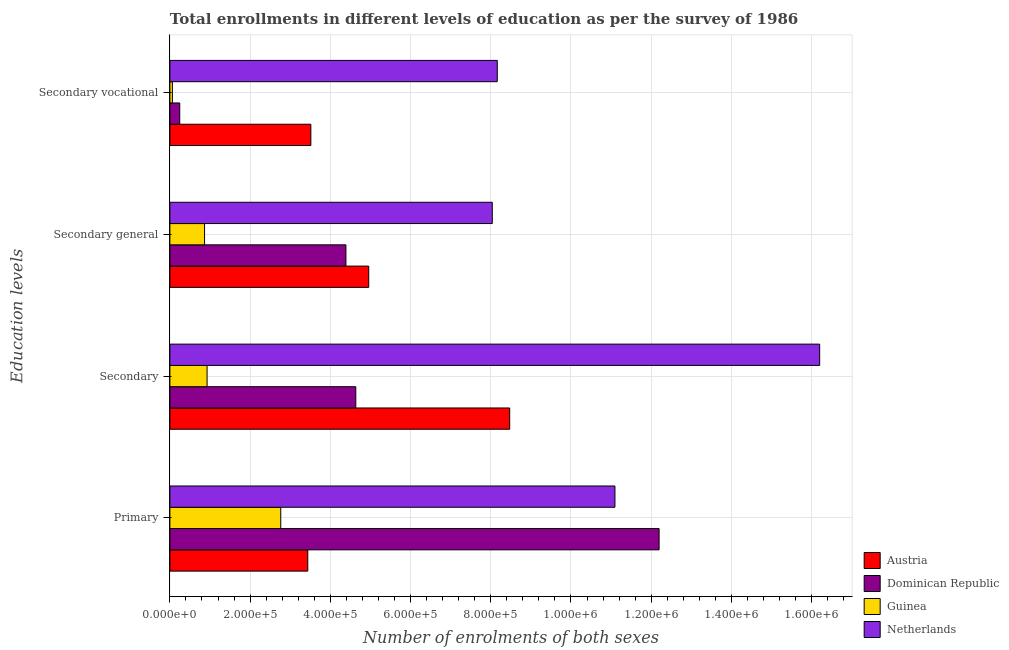Are the number of bars on each tick of the Y-axis equal?
Your response must be concise. Yes. How many bars are there on the 4th tick from the top?
Your answer should be compact. 4. What is the label of the 4th group of bars from the top?
Your response must be concise. Primary. What is the number of enrolments in primary education in Dominican Republic?
Keep it short and to the point. 1.22e+06. Across all countries, what is the maximum number of enrolments in secondary education?
Your answer should be compact. 1.62e+06. Across all countries, what is the minimum number of enrolments in primary education?
Make the answer very short. 2.76e+05. In which country was the number of enrolments in secondary general education minimum?
Offer a very short reply. Guinea. What is the total number of enrolments in primary education in the graph?
Provide a succinct answer. 2.95e+06. What is the difference between the number of enrolments in primary education in Netherlands and that in Dominican Republic?
Offer a very short reply. -1.10e+05. What is the difference between the number of enrolments in secondary general education in Austria and the number of enrolments in secondary vocational education in Dominican Republic?
Provide a short and direct response. 4.71e+05. What is the average number of enrolments in primary education per country?
Your answer should be compact. 7.37e+05. What is the difference between the number of enrolments in secondary education and number of enrolments in secondary vocational education in Netherlands?
Offer a terse response. 8.04e+05. What is the ratio of the number of enrolments in secondary vocational education in Dominican Republic to that in Guinea?
Your response must be concise. 3.92. Is the number of enrolments in secondary education in Austria less than that in Netherlands?
Keep it short and to the point. Yes. What is the difference between the highest and the second highest number of enrolments in primary education?
Provide a short and direct response. 1.10e+05. What is the difference between the highest and the lowest number of enrolments in secondary education?
Your answer should be very brief. 1.53e+06. In how many countries, is the number of enrolments in primary education greater than the average number of enrolments in primary education taken over all countries?
Your answer should be very brief. 2. What does the 2nd bar from the bottom in Primary represents?
Your answer should be compact. Dominican Republic. Is it the case that in every country, the sum of the number of enrolments in primary education and number of enrolments in secondary education is greater than the number of enrolments in secondary general education?
Provide a short and direct response. Yes. How many bars are there?
Provide a short and direct response. 16. How many countries are there in the graph?
Your answer should be very brief. 4. Are the values on the major ticks of X-axis written in scientific E-notation?
Ensure brevity in your answer.  Yes. Where does the legend appear in the graph?
Offer a terse response. Bottom right. How many legend labels are there?
Offer a very short reply. 4. What is the title of the graph?
Provide a succinct answer. Total enrollments in different levels of education as per the survey of 1986. What is the label or title of the X-axis?
Keep it short and to the point. Number of enrolments of both sexes. What is the label or title of the Y-axis?
Offer a very short reply. Education levels. What is the Number of enrolments of both sexes of Austria in Primary?
Provide a succinct answer. 3.44e+05. What is the Number of enrolments of both sexes in Dominican Republic in Primary?
Your response must be concise. 1.22e+06. What is the Number of enrolments of both sexes in Guinea in Primary?
Your answer should be compact. 2.76e+05. What is the Number of enrolments of both sexes of Netherlands in Primary?
Ensure brevity in your answer.  1.11e+06. What is the Number of enrolments of both sexes of Austria in Secondary?
Offer a terse response. 8.47e+05. What is the Number of enrolments of both sexes of Dominican Republic in Secondary?
Your response must be concise. 4.64e+05. What is the Number of enrolments of both sexes of Guinea in Secondary?
Provide a short and direct response. 9.28e+04. What is the Number of enrolments of both sexes of Netherlands in Secondary?
Keep it short and to the point. 1.62e+06. What is the Number of enrolments of both sexes in Austria in Secondary general?
Provide a succinct answer. 4.96e+05. What is the Number of enrolments of both sexes of Dominican Republic in Secondary general?
Your answer should be very brief. 4.39e+05. What is the Number of enrolments of both sexes of Guinea in Secondary general?
Offer a very short reply. 8.65e+04. What is the Number of enrolments of both sexes in Netherlands in Secondary general?
Provide a succinct answer. 8.04e+05. What is the Number of enrolments of both sexes in Austria in Secondary vocational?
Your answer should be very brief. 3.51e+05. What is the Number of enrolments of both sexes of Dominican Republic in Secondary vocational?
Provide a short and direct response. 2.46e+04. What is the Number of enrolments of both sexes of Guinea in Secondary vocational?
Keep it short and to the point. 6280. What is the Number of enrolments of both sexes in Netherlands in Secondary vocational?
Offer a terse response. 8.16e+05. Across all Education levels, what is the maximum Number of enrolments of both sexes in Austria?
Offer a terse response. 8.47e+05. Across all Education levels, what is the maximum Number of enrolments of both sexes in Dominican Republic?
Ensure brevity in your answer.  1.22e+06. Across all Education levels, what is the maximum Number of enrolments of both sexes of Guinea?
Give a very brief answer. 2.76e+05. Across all Education levels, what is the maximum Number of enrolments of both sexes in Netherlands?
Give a very brief answer. 1.62e+06. Across all Education levels, what is the minimum Number of enrolments of both sexes in Austria?
Offer a very short reply. 3.44e+05. Across all Education levels, what is the minimum Number of enrolments of both sexes of Dominican Republic?
Provide a succinct answer. 2.46e+04. Across all Education levels, what is the minimum Number of enrolments of both sexes of Guinea?
Your response must be concise. 6280. Across all Education levels, what is the minimum Number of enrolments of both sexes in Netherlands?
Offer a terse response. 8.04e+05. What is the total Number of enrolments of both sexes in Austria in the graph?
Provide a succinct answer. 2.04e+06. What is the total Number of enrolments of both sexes of Dominican Republic in the graph?
Your response must be concise. 2.15e+06. What is the total Number of enrolments of both sexes in Guinea in the graph?
Provide a succinct answer. 4.62e+05. What is the total Number of enrolments of both sexes of Netherlands in the graph?
Keep it short and to the point. 4.35e+06. What is the difference between the Number of enrolments of both sexes of Austria in Primary and that in Secondary?
Offer a very short reply. -5.03e+05. What is the difference between the Number of enrolments of both sexes in Dominican Republic in Primary and that in Secondary?
Your response must be concise. 7.56e+05. What is the difference between the Number of enrolments of both sexes of Guinea in Primary and that in Secondary?
Offer a very short reply. 1.84e+05. What is the difference between the Number of enrolments of both sexes in Netherlands in Primary and that in Secondary?
Provide a short and direct response. -5.10e+05. What is the difference between the Number of enrolments of both sexes in Austria in Primary and that in Secondary general?
Your answer should be compact. -1.52e+05. What is the difference between the Number of enrolments of both sexes of Dominican Republic in Primary and that in Secondary general?
Ensure brevity in your answer.  7.81e+05. What is the difference between the Number of enrolments of both sexes in Guinea in Primary and that in Secondary general?
Give a very brief answer. 1.90e+05. What is the difference between the Number of enrolments of both sexes of Netherlands in Primary and that in Secondary general?
Ensure brevity in your answer.  3.06e+05. What is the difference between the Number of enrolments of both sexes in Austria in Primary and that in Secondary vocational?
Keep it short and to the point. -7610. What is the difference between the Number of enrolments of both sexes of Dominican Republic in Primary and that in Secondary vocational?
Offer a terse response. 1.20e+06. What is the difference between the Number of enrolments of both sexes of Guinea in Primary and that in Secondary vocational?
Your answer should be compact. 2.70e+05. What is the difference between the Number of enrolments of both sexes in Netherlands in Primary and that in Secondary vocational?
Provide a short and direct response. 2.93e+05. What is the difference between the Number of enrolments of both sexes in Austria in Secondary and that in Secondary general?
Provide a short and direct response. 3.51e+05. What is the difference between the Number of enrolments of both sexes of Dominican Republic in Secondary and that in Secondary general?
Your answer should be compact. 2.46e+04. What is the difference between the Number of enrolments of both sexes of Guinea in Secondary and that in Secondary general?
Offer a very short reply. 6280. What is the difference between the Number of enrolments of both sexes in Netherlands in Secondary and that in Secondary general?
Ensure brevity in your answer.  8.16e+05. What is the difference between the Number of enrolments of both sexes in Austria in Secondary and that in Secondary vocational?
Your answer should be very brief. 4.96e+05. What is the difference between the Number of enrolments of both sexes in Dominican Republic in Secondary and that in Secondary vocational?
Provide a short and direct response. 4.39e+05. What is the difference between the Number of enrolments of both sexes in Guinea in Secondary and that in Secondary vocational?
Ensure brevity in your answer.  8.65e+04. What is the difference between the Number of enrolments of both sexes in Netherlands in Secondary and that in Secondary vocational?
Your answer should be very brief. 8.04e+05. What is the difference between the Number of enrolments of both sexes of Austria in Secondary general and that in Secondary vocational?
Provide a succinct answer. 1.44e+05. What is the difference between the Number of enrolments of both sexes in Dominican Republic in Secondary general and that in Secondary vocational?
Your answer should be very brief. 4.14e+05. What is the difference between the Number of enrolments of both sexes in Guinea in Secondary general and that in Secondary vocational?
Keep it short and to the point. 8.02e+04. What is the difference between the Number of enrolments of both sexes of Netherlands in Secondary general and that in Secondary vocational?
Your response must be concise. -1.24e+04. What is the difference between the Number of enrolments of both sexes in Austria in Primary and the Number of enrolments of both sexes in Dominican Republic in Secondary?
Your answer should be very brief. -1.20e+05. What is the difference between the Number of enrolments of both sexes of Austria in Primary and the Number of enrolments of both sexes of Guinea in Secondary?
Your answer should be compact. 2.51e+05. What is the difference between the Number of enrolments of both sexes in Austria in Primary and the Number of enrolments of both sexes in Netherlands in Secondary?
Your answer should be very brief. -1.28e+06. What is the difference between the Number of enrolments of both sexes in Dominican Republic in Primary and the Number of enrolments of both sexes in Guinea in Secondary?
Give a very brief answer. 1.13e+06. What is the difference between the Number of enrolments of both sexes in Dominican Republic in Primary and the Number of enrolments of both sexes in Netherlands in Secondary?
Your answer should be very brief. -4.00e+05. What is the difference between the Number of enrolments of both sexes of Guinea in Primary and the Number of enrolments of both sexes of Netherlands in Secondary?
Keep it short and to the point. -1.34e+06. What is the difference between the Number of enrolments of both sexes in Austria in Primary and the Number of enrolments of both sexes in Dominican Republic in Secondary general?
Your answer should be very brief. -9.51e+04. What is the difference between the Number of enrolments of both sexes of Austria in Primary and the Number of enrolments of both sexes of Guinea in Secondary general?
Your answer should be very brief. 2.57e+05. What is the difference between the Number of enrolments of both sexes in Austria in Primary and the Number of enrolments of both sexes in Netherlands in Secondary general?
Your answer should be compact. -4.60e+05. What is the difference between the Number of enrolments of both sexes of Dominican Republic in Primary and the Number of enrolments of both sexes of Guinea in Secondary general?
Keep it short and to the point. 1.13e+06. What is the difference between the Number of enrolments of both sexes of Dominican Republic in Primary and the Number of enrolments of both sexes of Netherlands in Secondary general?
Your response must be concise. 4.16e+05. What is the difference between the Number of enrolments of both sexes of Guinea in Primary and the Number of enrolments of both sexes of Netherlands in Secondary general?
Keep it short and to the point. -5.27e+05. What is the difference between the Number of enrolments of both sexes of Austria in Primary and the Number of enrolments of both sexes of Dominican Republic in Secondary vocational?
Provide a succinct answer. 3.19e+05. What is the difference between the Number of enrolments of both sexes in Austria in Primary and the Number of enrolments of both sexes in Guinea in Secondary vocational?
Your answer should be very brief. 3.38e+05. What is the difference between the Number of enrolments of both sexes in Austria in Primary and the Number of enrolments of both sexes in Netherlands in Secondary vocational?
Keep it short and to the point. -4.72e+05. What is the difference between the Number of enrolments of both sexes in Dominican Republic in Primary and the Number of enrolments of both sexes in Guinea in Secondary vocational?
Your answer should be compact. 1.21e+06. What is the difference between the Number of enrolments of both sexes in Dominican Republic in Primary and the Number of enrolments of both sexes in Netherlands in Secondary vocational?
Your answer should be compact. 4.03e+05. What is the difference between the Number of enrolments of both sexes of Guinea in Primary and the Number of enrolments of both sexes of Netherlands in Secondary vocational?
Your answer should be compact. -5.40e+05. What is the difference between the Number of enrolments of both sexes in Austria in Secondary and the Number of enrolments of both sexes in Dominican Republic in Secondary general?
Keep it short and to the point. 4.08e+05. What is the difference between the Number of enrolments of both sexes in Austria in Secondary and the Number of enrolments of both sexes in Guinea in Secondary general?
Give a very brief answer. 7.61e+05. What is the difference between the Number of enrolments of both sexes of Austria in Secondary and the Number of enrolments of both sexes of Netherlands in Secondary general?
Offer a terse response. 4.34e+04. What is the difference between the Number of enrolments of both sexes in Dominican Republic in Secondary and the Number of enrolments of both sexes in Guinea in Secondary general?
Give a very brief answer. 3.77e+05. What is the difference between the Number of enrolments of both sexes in Dominican Republic in Secondary and the Number of enrolments of both sexes in Netherlands in Secondary general?
Your response must be concise. -3.40e+05. What is the difference between the Number of enrolments of both sexes of Guinea in Secondary and the Number of enrolments of both sexes of Netherlands in Secondary general?
Your response must be concise. -7.11e+05. What is the difference between the Number of enrolments of both sexes of Austria in Secondary and the Number of enrolments of both sexes of Dominican Republic in Secondary vocational?
Provide a succinct answer. 8.23e+05. What is the difference between the Number of enrolments of both sexes of Austria in Secondary and the Number of enrolments of both sexes of Guinea in Secondary vocational?
Make the answer very short. 8.41e+05. What is the difference between the Number of enrolments of both sexes of Austria in Secondary and the Number of enrolments of both sexes of Netherlands in Secondary vocational?
Your answer should be very brief. 3.10e+04. What is the difference between the Number of enrolments of both sexes in Dominican Republic in Secondary and the Number of enrolments of both sexes in Guinea in Secondary vocational?
Ensure brevity in your answer.  4.57e+05. What is the difference between the Number of enrolments of both sexes of Dominican Republic in Secondary and the Number of enrolments of both sexes of Netherlands in Secondary vocational?
Give a very brief answer. -3.53e+05. What is the difference between the Number of enrolments of both sexes of Guinea in Secondary and the Number of enrolments of both sexes of Netherlands in Secondary vocational?
Your response must be concise. -7.23e+05. What is the difference between the Number of enrolments of both sexes in Austria in Secondary general and the Number of enrolments of both sexes in Dominican Republic in Secondary vocational?
Offer a terse response. 4.71e+05. What is the difference between the Number of enrolments of both sexes in Austria in Secondary general and the Number of enrolments of both sexes in Guinea in Secondary vocational?
Your answer should be compact. 4.89e+05. What is the difference between the Number of enrolments of both sexes of Austria in Secondary general and the Number of enrolments of both sexes of Netherlands in Secondary vocational?
Your response must be concise. -3.20e+05. What is the difference between the Number of enrolments of both sexes of Dominican Republic in Secondary general and the Number of enrolments of both sexes of Guinea in Secondary vocational?
Make the answer very short. 4.33e+05. What is the difference between the Number of enrolments of both sexes of Dominican Republic in Secondary general and the Number of enrolments of both sexes of Netherlands in Secondary vocational?
Give a very brief answer. -3.77e+05. What is the difference between the Number of enrolments of both sexes of Guinea in Secondary general and the Number of enrolments of both sexes of Netherlands in Secondary vocational?
Offer a very short reply. -7.30e+05. What is the average Number of enrolments of both sexes of Austria per Education levels?
Ensure brevity in your answer.  5.10e+05. What is the average Number of enrolments of both sexes in Dominican Republic per Education levels?
Provide a succinct answer. 5.37e+05. What is the average Number of enrolments of both sexes of Guinea per Education levels?
Make the answer very short. 1.15e+05. What is the average Number of enrolments of both sexes of Netherlands per Education levels?
Provide a short and direct response. 1.09e+06. What is the difference between the Number of enrolments of both sexes in Austria and Number of enrolments of both sexes in Dominican Republic in Primary?
Your answer should be compact. -8.76e+05. What is the difference between the Number of enrolments of both sexes in Austria and Number of enrolments of both sexes in Guinea in Primary?
Keep it short and to the point. 6.74e+04. What is the difference between the Number of enrolments of both sexes of Austria and Number of enrolments of both sexes of Netherlands in Primary?
Your answer should be very brief. -7.66e+05. What is the difference between the Number of enrolments of both sexes of Dominican Republic and Number of enrolments of both sexes of Guinea in Primary?
Make the answer very short. 9.43e+05. What is the difference between the Number of enrolments of both sexes in Dominican Republic and Number of enrolments of both sexes in Netherlands in Primary?
Make the answer very short. 1.10e+05. What is the difference between the Number of enrolments of both sexes in Guinea and Number of enrolments of both sexes in Netherlands in Primary?
Your answer should be compact. -8.33e+05. What is the difference between the Number of enrolments of both sexes of Austria and Number of enrolments of both sexes of Dominican Republic in Secondary?
Make the answer very short. 3.84e+05. What is the difference between the Number of enrolments of both sexes of Austria and Number of enrolments of both sexes of Guinea in Secondary?
Offer a terse response. 7.54e+05. What is the difference between the Number of enrolments of both sexes in Austria and Number of enrolments of both sexes in Netherlands in Secondary?
Give a very brief answer. -7.73e+05. What is the difference between the Number of enrolments of both sexes in Dominican Republic and Number of enrolments of both sexes in Guinea in Secondary?
Provide a short and direct response. 3.71e+05. What is the difference between the Number of enrolments of both sexes in Dominican Republic and Number of enrolments of both sexes in Netherlands in Secondary?
Make the answer very short. -1.16e+06. What is the difference between the Number of enrolments of both sexes in Guinea and Number of enrolments of both sexes in Netherlands in Secondary?
Give a very brief answer. -1.53e+06. What is the difference between the Number of enrolments of both sexes in Austria and Number of enrolments of both sexes in Dominican Republic in Secondary general?
Give a very brief answer. 5.68e+04. What is the difference between the Number of enrolments of both sexes of Austria and Number of enrolments of both sexes of Guinea in Secondary general?
Your response must be concise. 4.09e+05. What is the difference between the Number of enrolments of both sexes in Austria and Number of enrolments of both sexes in Netherlands in Secondary general?
Offer a very short reply. -3.08e+05. What is the difference between the Number of enrolments of both sexes of Dominican Republic and Number of enrolments of both sexes of Guinea in Secondary general?
Provide a short and direct response. 3.52e+05. What is the difference between the Number of enrolments of both sexes in Dominican Republic and Number of enrolments of both sexes in Netherlands in Secondary general?
Give a very brief answer. -3.65e+05. What is the difference between the Number of enrolments of both sexes in Guinea and Number of enrolments of both sexes in Netherlands in Secondary general?
Your answer should be compact. -7.17e+05. What is the difference between the Number of enrolments of both sexes of Austria and Number of enrolments of both sexes of Dominican Republic in Secondary vocational?
Your answer should be compact. 3.27e+05. What is the difference between the Number of enrolments of both sexes of Austria and Number of enrolments of both sexes of Guinea in Secondary vocational?
Make the answer very short. 3.45e+05. What is the difference between the Number of enrolments of both sexes in Austria and Number of enrolments of both sexes in Netherlands in Secondary vocational?
Your response must be concise. -4.65e+05. What is the difference between the Number of enrolments of both sexes of Dominican Republic and Number of enrolments of both sexes of Guinea in Secondary vocational?
Keep it short and to the point. 1.83e+04. What is the difference between the Number of enrolments of both sexes in Dominican Republic and Number of enrolments of both sexes in Netherlands in Secondary vocational?
Keep it short and to the point. -7.92e+05. What is the difference between the Number of enrolments of both sexes in Guinea and Number of enrolments of both sexes in Netherlands in Secondary vocational?
Offer a terse response. -8.10e+05. What is the ratio of the Number of enrolments of both sexes of Austria in Primary to that in Secondary?
Keep it short and to the point. 0.41. What is the ratio of the Number of enrolments of both sexes in Dominican Republic in Primary to that in Secondary?
Provide a short and direct response. 2.63. What is the ratio of the Number of enrolments of both sexes of Guinea in Primary to that in Secondary?
Keep it short and to the point. 2.98. What is the ratio of the Number of enrolments of both sexes of Netherlands in Primary to that in Secondary?
Offer a very short reply. 0.68. What is the ratio of the Number of enrolments of both sexes of Austria in Primary to that in Secondary general?
Ensure brevity in your answer.  0.69. What is the ratio of the Number of enrolments of both sexes of Dominican Republic in Primary to that in Secondary general?
Provide a succinct answer. 2.78. What is the ratio of the Number of enrolments of both sexes of Guinea in Primary to that in Secondary general?
Provide a short and direct response. 3.2. What is the ratio of the Number of enrolments of both sexes of Netherlands in Primary to that in Secondary general?
Your answer should be compact. 1.38. What is the ratio of the Number of enrolments of both sexes in Austria in Primary to that in Secondary vocational?
Offer a very short reply. 0.98. What is the ratio of the Number of enrolments of both sexes in Dominican Republic in Primary to that in Secondary vocational?
Your response must be concise. 49.6. What is the ratio of the Number of enrolments of both sexes in Guinea in Primary to that in Secondary vocational?
Keep it short and to the point. 44.02. What is the ratio of the Number of enrolments of both sexes of Netherlands in Primary to that in Secondary vocational?
Provide a short and direct response. 1.36. What is the ratio of the Number of enrolments of both sexes in Austria in Secondary to that in Secondary general?
Make the answer very short. 1.71. What is the ratio of the Number of enrolments of both sexes of Dominican Republic in Secondary to that in Secondary general?
Give a very brief answer. 1.06. What is the ratio of the Number of enrolments of both sexes in Guinea in Secondary to that in Secondary general?
Your answer should be compact. 1.07. What is the ratio of the Number of enrolments of both sexes in Netherlands in Secondary to that in Secondary general?
Offer a very short reply. 2.02. What is the ratio of the Number of enrolments of both sexes in Austria in Secondary to that in Secondary vocational?
Provide a succinct answer. 2.41. What is the ratio of the Number of enrolments of both sexes in Dominican Republic in Secondary to that in Secondary vocational?
Keep it short and to the point. 18.85. What is the ratio of the Number of enrolments of both sexes of Guinea in Secondary to that in Secondary vocational?
Keep it short and to the point. 14.77. What is the ratio of the Number of enrolments of both sexes in Netherlands in Secondary to that in Secondary vocational?
Provide a short and direct response. 1.98. What is the ratio of the Number of enrolments of both sexes of Austria in Secondary general to that in Secondary vocational?
Keep it short and to the point. 1.41. What is the ratio of the Number of enrolments of both sexes of Dominican Republic in Secondary general to that in Secondary vocational?
Your answer should be very brief. 17.85. What is the ratio of the Number of enrolments of both sexes in Guinea in Secondary general to that in Secondary vocational?
Provide a succinct answer. 13.77. What is the difference between the highest and the second highest Number of enrolments of both sexes of Austria?
Give a very brief answer. 3.51e+05. What is the difference between the highest and the second highest Number of enrolments of both sexes of Dominican Republic?
Offer a terse response. 7.56e+05. What is the difference between the highest and the second highest Number of enrolments of both sexes in Guinea?
Give a very brief answer. 1.84e+05. What is the difference between the highest and the second highest Number of enrolments of both sexes of Netherlands?
Your response must be concise. 5.10e+05. What is the difference between the highest and the lowest Number of enrolments of both sexes of Austria?
Make the answer very short. 5.03e+05. What is the difference between the highest and the lowest Number of enrolments of both sexes of Dominican Republic?
Your response must be concise. 1.20e+06. What is the difference between the highest and the lowest Number of enrolments of both sexes in Guinea?
Your answer should be compact. 2.70e+05. What is the difference between the highest and the lowest Number of enrolments of both sexes in Netherlands?
Make the answer very short. 8.16e+05. 